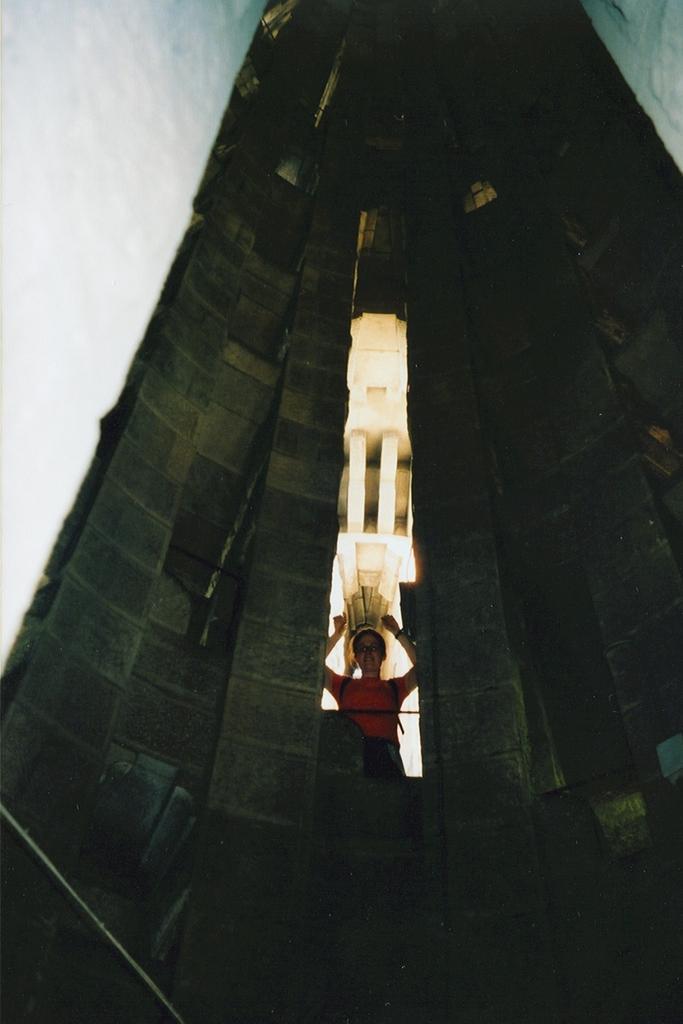In one or two sentences, can you explain what this image depicts? In this image there is a building and there is a lady standing. In the background there is the sky. 